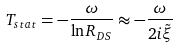<formula> <loc_0><loc_0><loc_500><loc_500>T _ { s t a t } = - \frac { \omega } { \ln R _ { D S } } \approx - \frac { \omega } { 2 i \tilde { \xi } }</formula> 